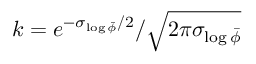<formula> <loc_0><loc_0><loc_500><loc_500>k = e ^ { - \sigma _ { \log \bar { \phi } } / 2 } / \sqrt { 2 \pi \sigma _ { \log \bar { \phi } } }</formula> 